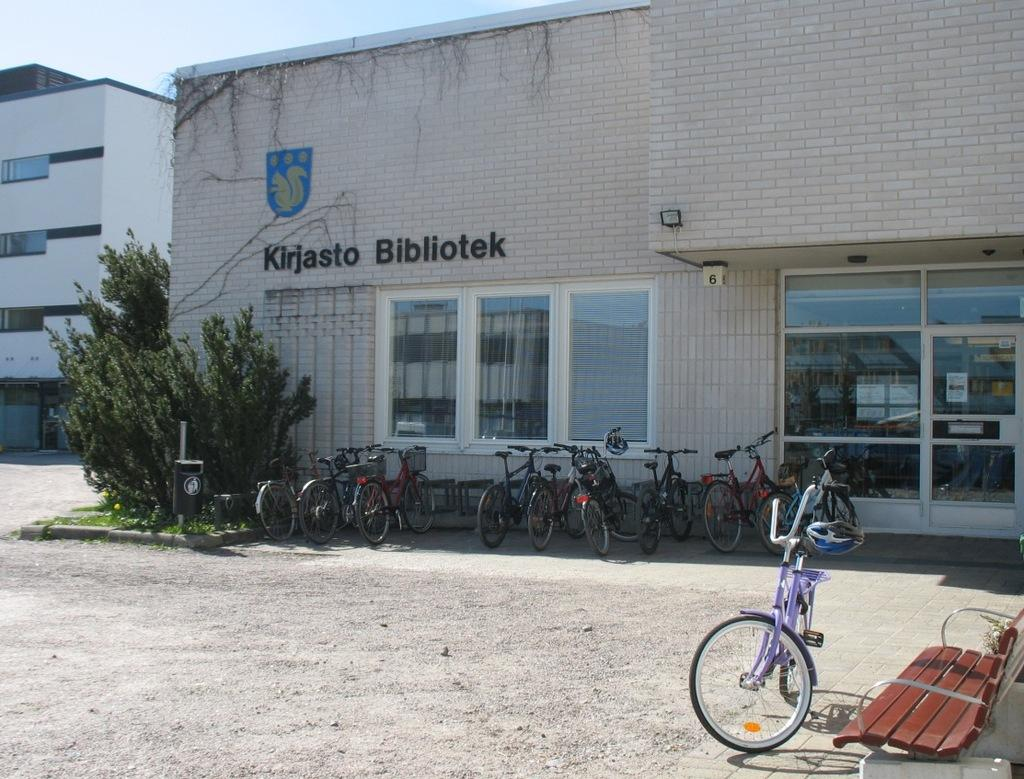What type of structures can be seen in the image? There are buildings in the image. What other natural elements are present in the image? There are trees in the image. What mode of transportation is visible in the image? Bicycles are visible in the image. Where is the bench located in the image? The bench is on the right side of the image. What can be seen in the distance in the image? The sky is visible in the background of the image. How many thumbs are visible on the bicycles in the image? There are no visible thumbs on the bicycles in the image. What type of animals are grazing in the background of the image? There are no animals present in the image; it features buildings, trees, bicycles, a bench, and the sky. 